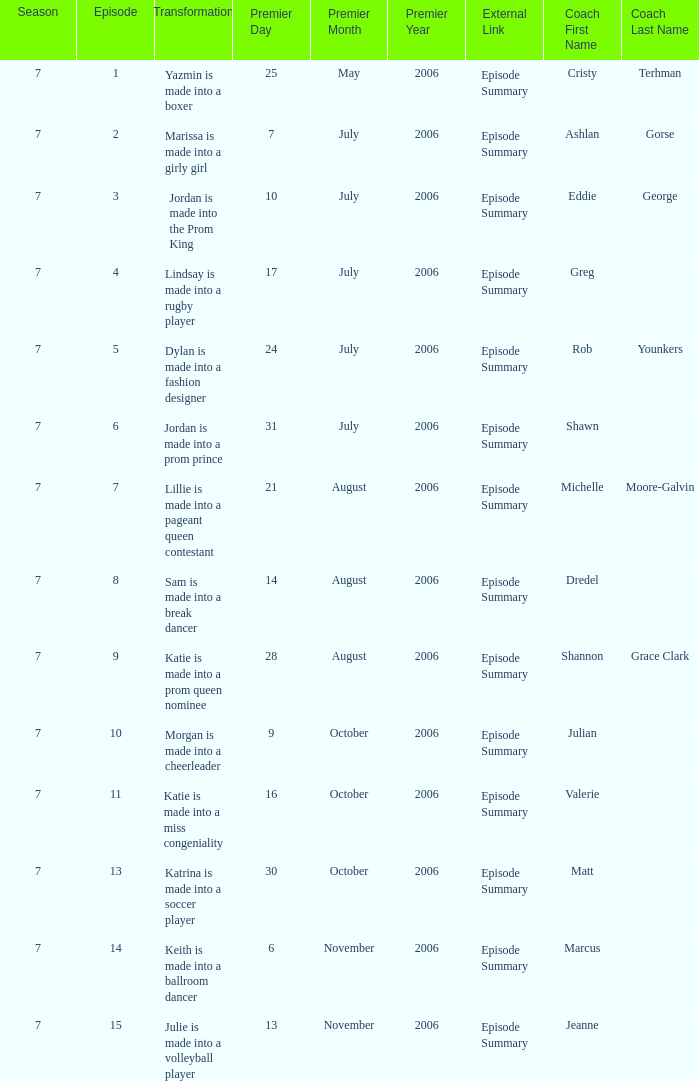How many episodes have Valerie? 1.0. 